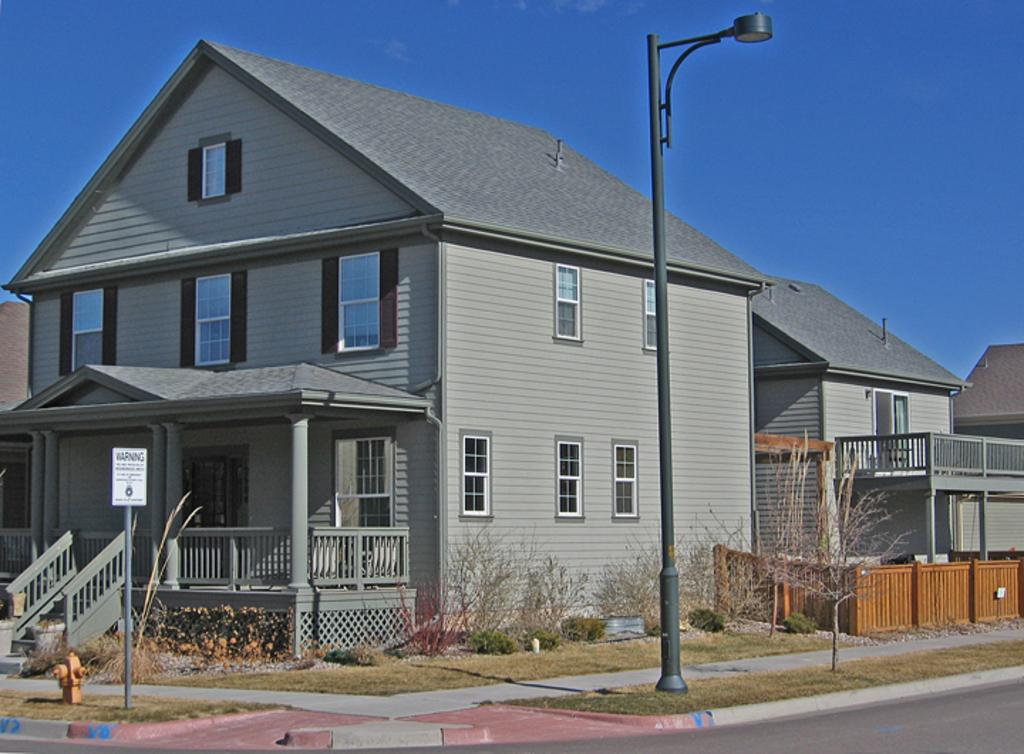What is the main feature of the image? There is a road in the image. What type of vegetation can be seen in the image? Grass and plants are visible in the image. What structures are present in the image? Fences, pillars, buildings with windows, a signboard, a street lamp, and poles are present in the image. What other objects can be seen in the image? A hydrant is visible in the image. What is visible in the background of the image? The sky is visible in the background of the image. What rule is being enforced by the knowledge in the image? There is no knowledge present in the image, and therefore no rule can be enforced. Can you touch the touch in the image? There is no touchable object in the image, as the provided facts do not mention anything that can be touched. 